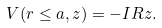Convert formula to latex. <formula><loc_0><loc_0><loc_500><loc_500>V ( r \leq a , z ) = - I R z .</formula> 